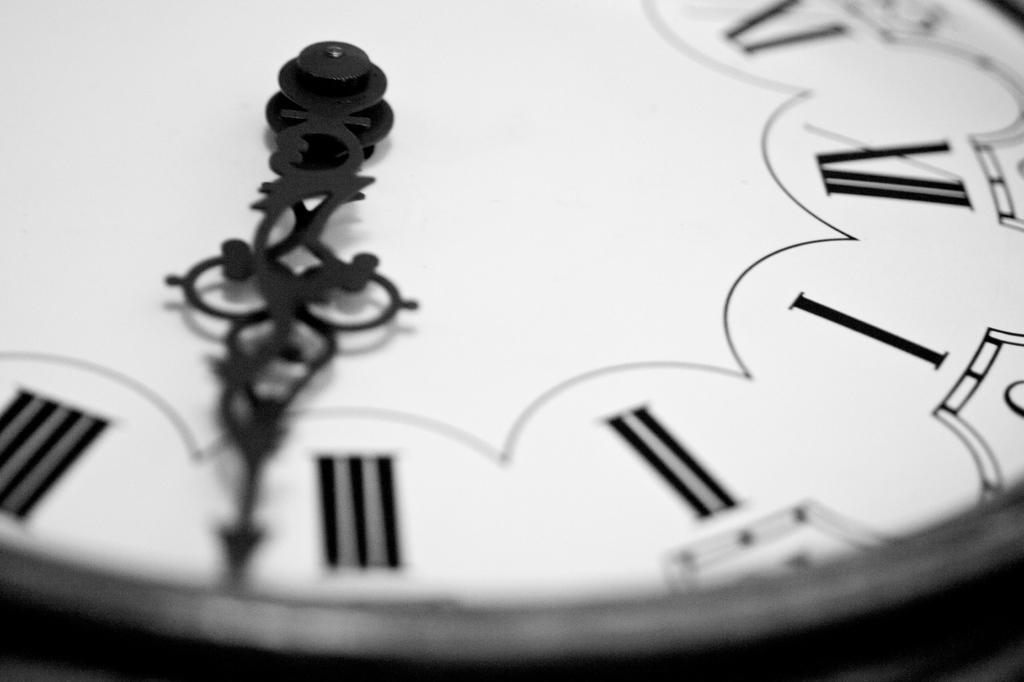<image>
Present a compact description of the photo's key features. A black and white close up of portion of a clock shows both hands almost half past three. 